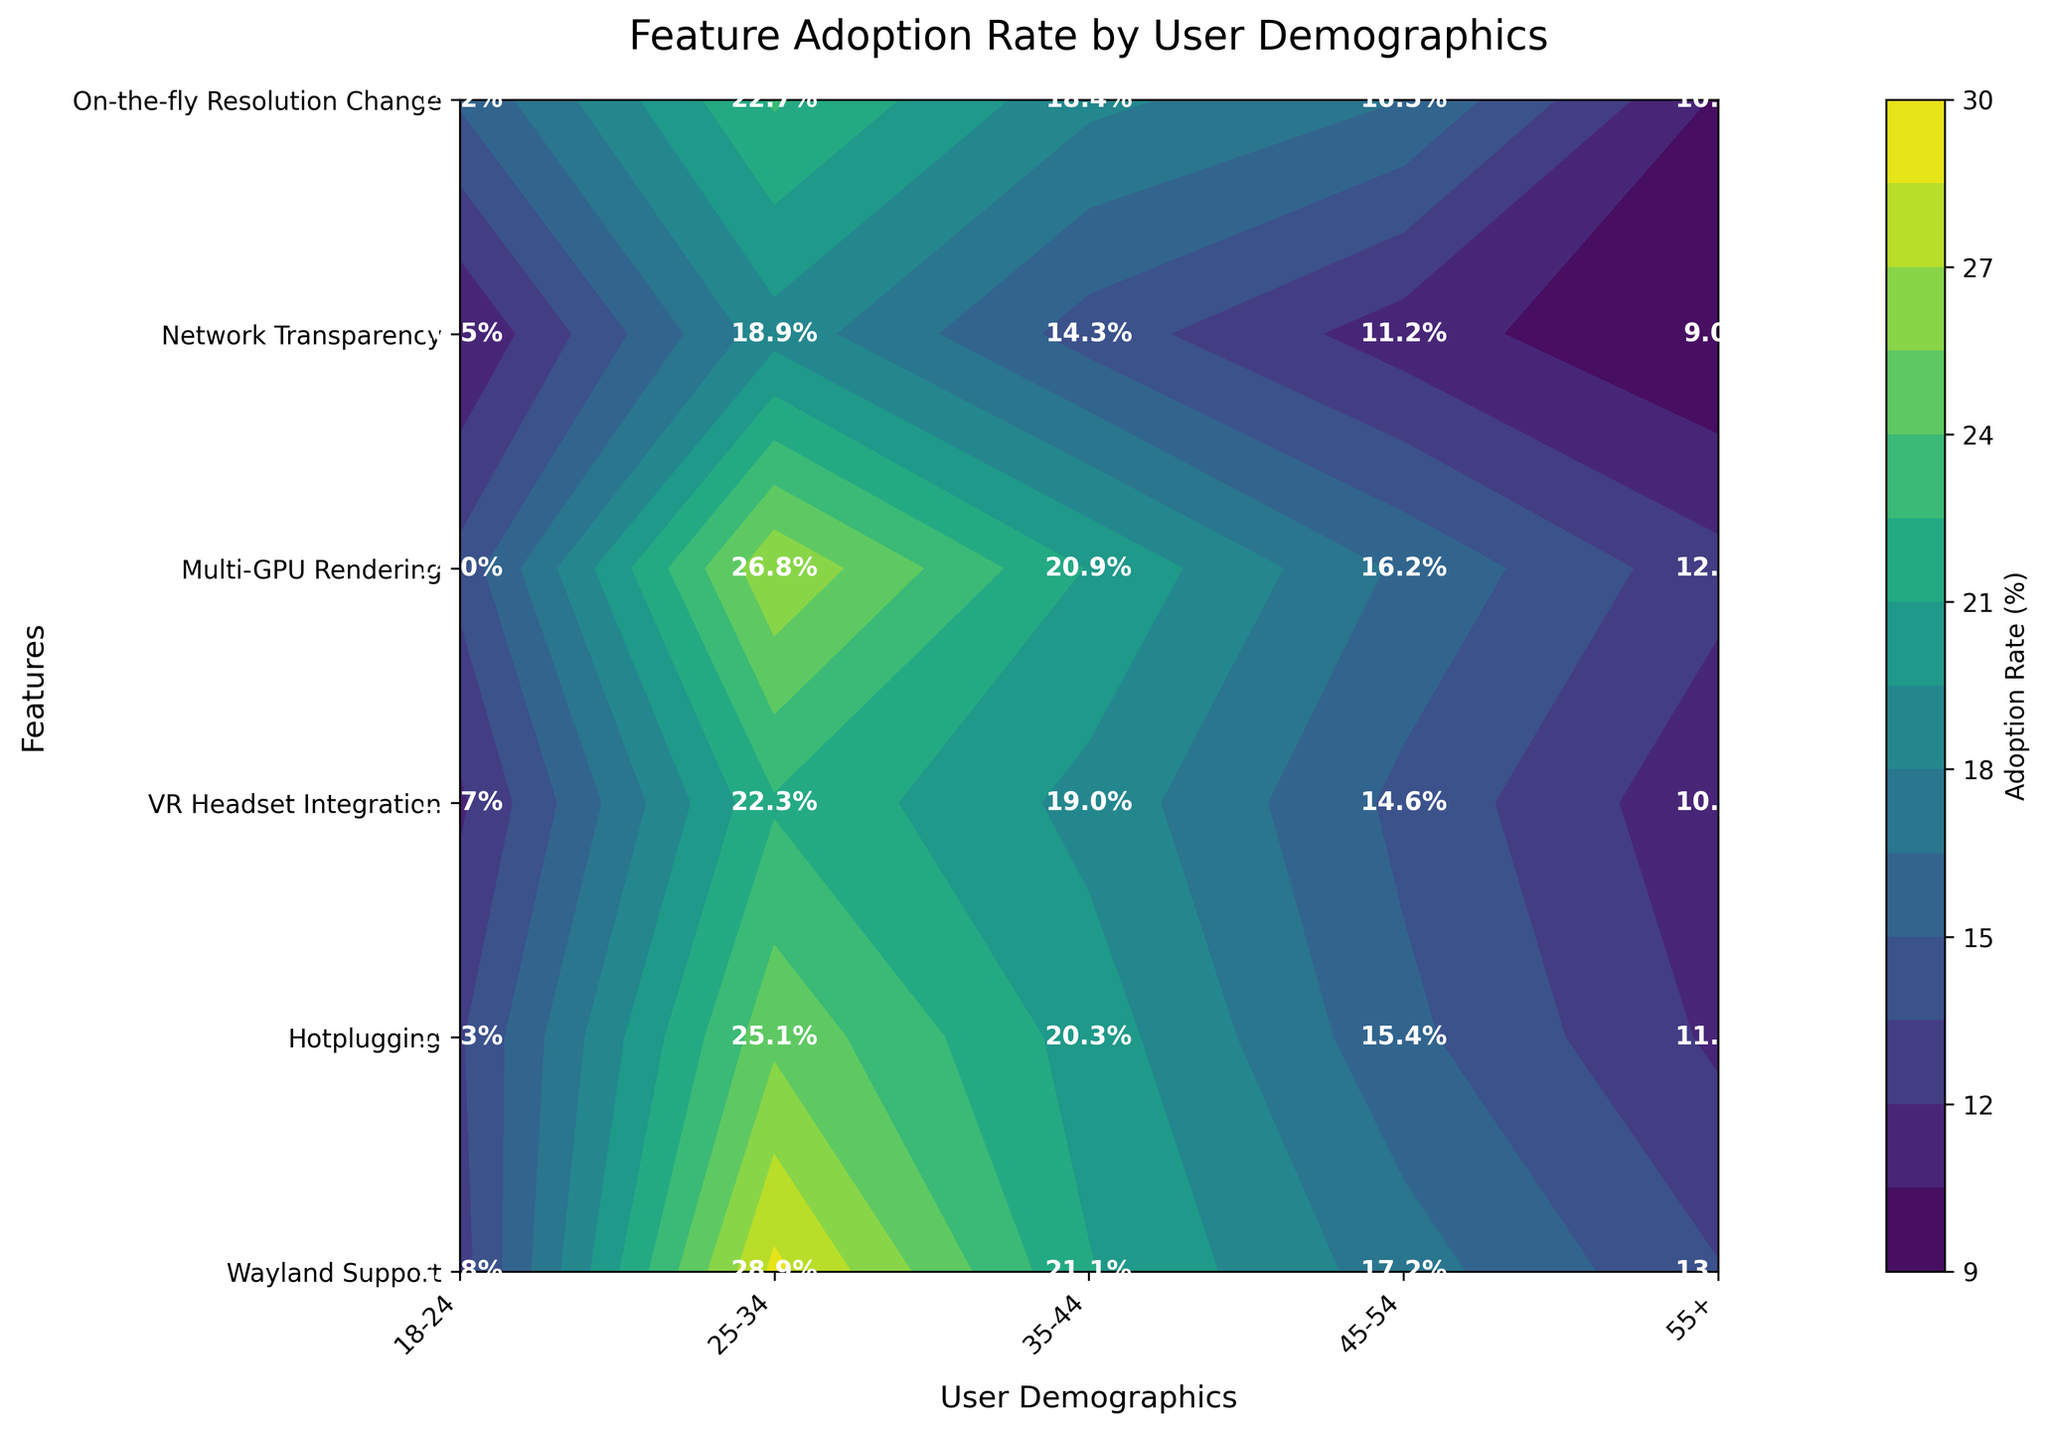What is the adoption rate of Wayland Support for the 25-34 age group? To find the adoption rate for Wayland Support for the 25-34 age group, you need to locate the intersection of "Wayland Support" on the y-axis and "25-34" on the x-axis. The value at this intersection is 22.7%.
Answer: 22.7% Which feature has the highest adoption rate for the 25-34 age group? To determine which feature has the highest adoption rate for the 25-34 age group, look vertically at the column for the 25-34 age group and identify the highest number. The highest number in this column is 28.9%, which corresponds to the feature "Hotplugging."
Answer: Hotplugging What is the difference in the adoption rates of VR Headset Integration between the 18-24 and 25-34 age groups? The adoption rate of VR Headset Integration for 18-24 age group is 10.5%, and for the 25-34 age group, it is 18.9%. The difference is calculated as 18.9% - 10.5% = 8.4%.
Answer: 8.4% Which demographic group has the lowest adoption rate for Multi-GPU Rendering? To find the demographic group with the lowest adoption rate for Multi-GPU Rendering, examine the row corresponding to "Multi-GPU Rendering" and identify the smallest value. The smallest value in this row is 11.7%, which corresponds to the "55+" age group.
Answer: 55+ How does the adoption rate for Hotplugging in the 35-44 age group compare to Network Transparency in the same age group? Look at the values for "Hotplugging" and "Network Transparency" in the 35-44 age group. Hotplugging for 35-44 is 21.1% and Network Transparency for 35-44 is 19.0%. Comparing these, 21.1% is greater than 19.0%.
Answer: Hotplugging is higher What feature has the most consistent adoption rate across all demographic groups? To find the feature with the most consistent adoption rate, examine the variance of adoption rates within each feature row. "Wayland Support" shows consistent values, ranging from 10.3% to 22.7%, a lesser range compared to other features.
Answer: Wayland Support What is the average adoption rate for On-the-fly Resolution Change across all age groups? To find the average adoption rate, add all the adoption rates for On-the-fly Resolution Change, which are 14.0%, 26.8%, 20.9%, 16.2%, and 12.5%, and then divide by the number of groups. (14.0 + 26.8 + 20.9 + 16.2 + 12.5) / 5 = 18.08%.
Answer: 18.08% Which user demographic shows the highest overall adoption rate across all features? To identify the user demographic with the highest overall adoption rate, sum the adoption rates across all features for each demographic group and compare the sums. The 25-34 group has the highest cumulative adoption rates.
Answer: 25-34 How does the adoption rate of Wayland Support in the 45-54 age group compare to the adoption rate of Multi-GPU Rendering in the same age group? Check the values for "Wayland Support" and "Multi-GPU Rendering" in the 45-54 age group. Wayland Support is 16.5%, and Multi-GPU Rendering is 15.4%. Therefore, Wayland Support is higher.
Answer: Wayland Support is higher What is the total variance in adoption rates for Network Transparency across all user demographics? Calculate the variance by first finding the individual adoption rates for Network Transparency (11.7%, 22.3%, 19.0%, 14.6%, and 10.8%). Then, find the mean of these rates and the sum of squared differences from the mean, and finally, divide by the number of rates minus one.
Answer: Calculation needed 